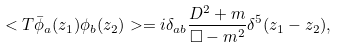<formula> <loc_0><loc_0><loc_500><loc_500>< T \bar { \phi } _ { a } ( z _ { 1 } ) \phi _ { b } ( z _ { 2 } ) > = i \delta _ { a b } \frac { D ^ { 2 } + m } { \Box - m ^ { 2 } } \delta ^ { 5 } ( z _ { 1 } - z _ { 2 } ) ,</formula> 